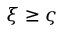<formula> <loc_0><loc_0><loc_500><loc_500>\xi \geq \varsigma</formula> 